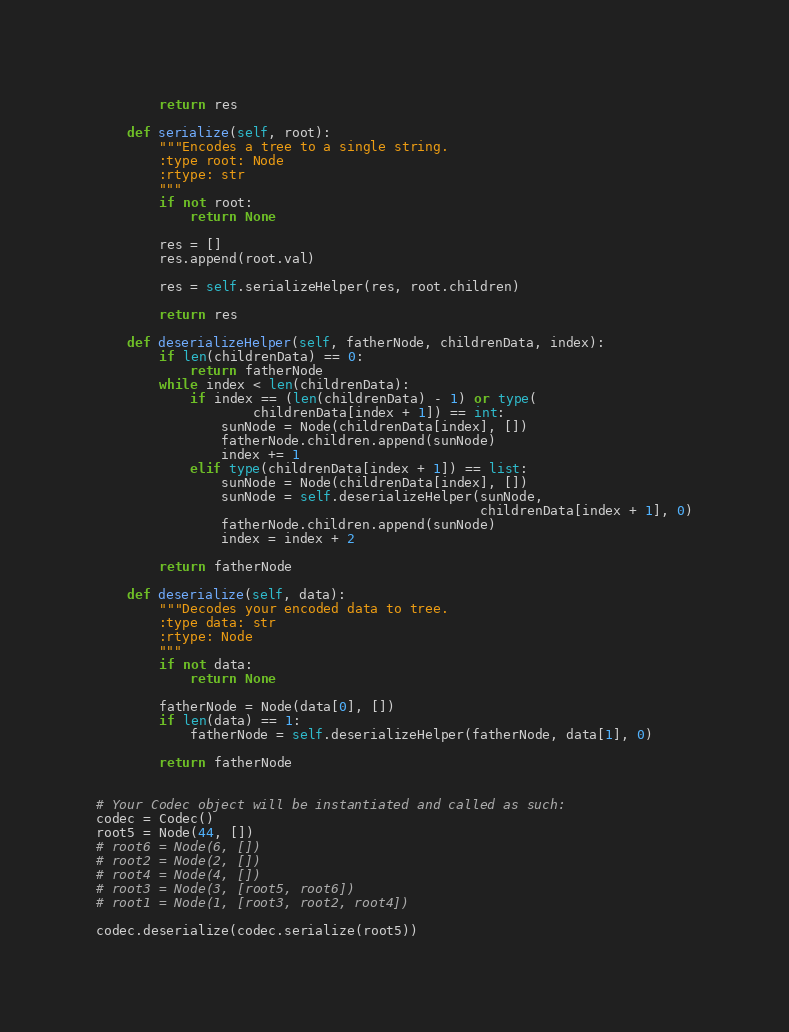Convert code to text. <code><loc_0><loc_0><loc_500><loc_500><_Python_>        return res

    def serialize(self, root):
        """Encodes a tree to a single string.
        :type root: Node
        :rtype: str
        """
        if not root:
            return None

        res = []
        res.append(root.val)

        res = self.serializeHelper(res, root.children)

        return res

    def deserializeHelper(self, fatherNode, childrenData, index):
        if len(childrenData) == 0:
            return fatherNode
        while index < len(childrenData):
            if index == (len(childrenData) - 1) or type(
                    childrenData[index + 1]) == int:
                sunNode = Node(childrenData[index], [])
                fatherNode.children.append(sunNode)
                index += 1
            elif type(childrenData[index + 1]) == list:
                sunNode = Node(childrenData[index], [])
                sunNode = self.deserializeHelper(sunNode,
                                                 childrenData[index + 1], 0)
                fatherNode.children.append(sunNode)
                index = index + 2

        return fatherNode

    def deserialize(self, data):
        """Decodes your encoded data to tree.
        :type data: str
        :rtype: Node
        """
        if not data:
            return None

        fatherNode = Node(data[0], [])
        if len(data) == 1:
            fatherNode = self.deserializeHelper(fatherNode, data[1], 0)

        return fatherNode


# Your Codec object will be instantiated and called as such:
codec = Codec()
root5 = Node(44, [])
# root6 = Node(6, [])
# root2 = Node(2, [])
# root4 = Node(4, [])
# root3 = Node(3, [root5, root6])
# root1 = Node(1, [root3, root2, root4])

codec.deserialize(codec.serialize(root5))
</code> 